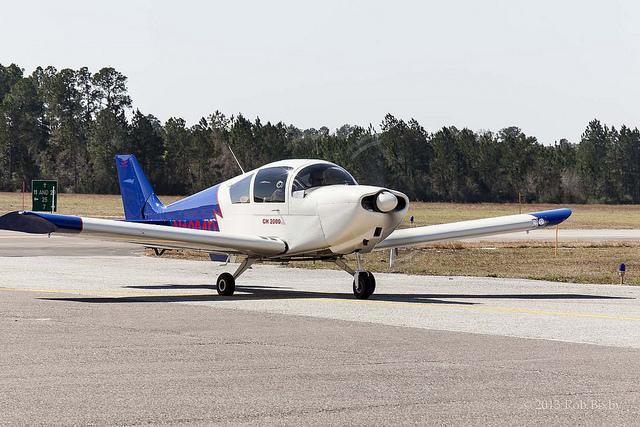How many men in blue shirts?
Give a very brief answer. 0. 